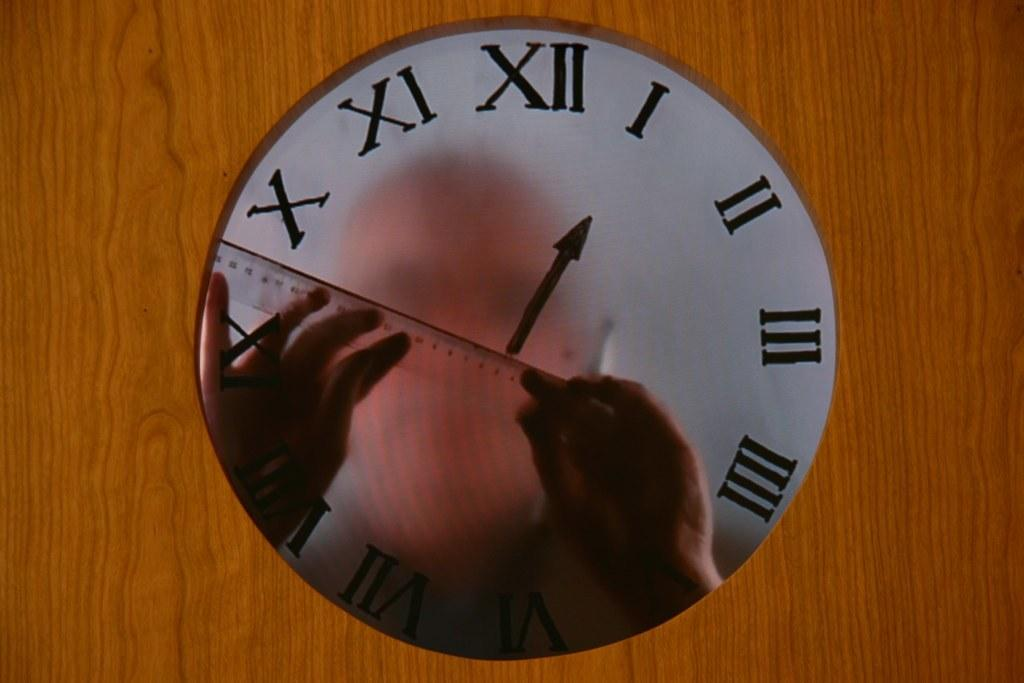<image>
Summarize the visual content of the image. A see through clock pointing to the number 1 shows a man with a ruler on the other side 